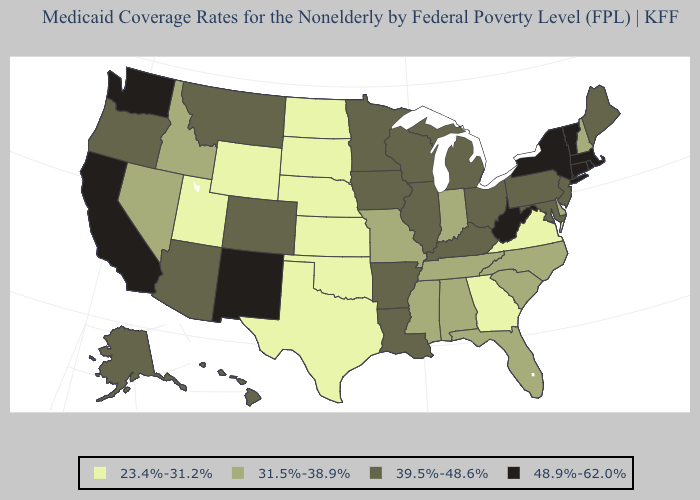Does Washington have the highest value in the USA?
Answer briefly. Yes. Name the states that have a value in the range 39.5%-48.6%?
Short answer required. Alaska, Arizona, Arkansas, Colorado, Hawaii, Illinois, Iowa, Kentucky, Louisiana, Maine, Maryland, Michigan, Minnesota, Montana, New Jersey, Ohio, Oregon, Pennsylvania, Wisconsin. What is the value of Nebraska?
Short answer required. 23.4%-31.2%. Name the states that have a value in the range 39.5%-48.6%?
Answer briefly. Alaska, Arizona, Arkansas, Colorado, Hawaii, Illinois, Iowa, Kentucky, Louisiana, Maine, Maryland, Michigan, Minnesota, Montana, New Jersey, Ohio, Oregon, Pennsylvania, Wisconsin. Does the map have missing data?
Answer briefly. No. How many symbols are there in the legend?
Write a very short answer. 4. Which states have the lowest value in the USA?
Keep it brief. Georgia, Kansas, Nebraska, North Dakota, Oklahoma, South Dakota, Texas, Utah, Virginia, Wyoming. Does Utah have the lowest value in the West?
Write a very short answer. Yes. Which states have the highest value in the USA?
Quick response, please. California, Connecticut, Massachusetts, New Mexico, New York, Rhode Island, Vermont, Washington, West Virginia. What is the highest value in states that border Maine?
Concise answer only. 31.5%-38.9%. What is the highest value in states that border New Jersey?
Quick response, please. 48.9%-62.0%. What is the lowest value in the USA?
Give a very brief answer. 23.4%-31.2%. Does Ohio have a higher value than Utah?
Quick response, please. Yes. Among the states that border Tennessee , does Alabama have the lowest value?
Keep it brief. No. Which states have the lowest value in the USA?
Give a very brief answer. Georgia, Kansas, Nebraska, North Dakota, Oklahoma, South Dakota, Texas, Utah, Virginia, Wyoming. 